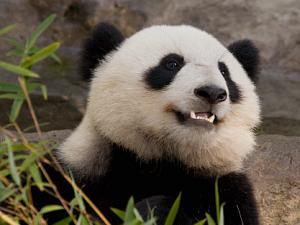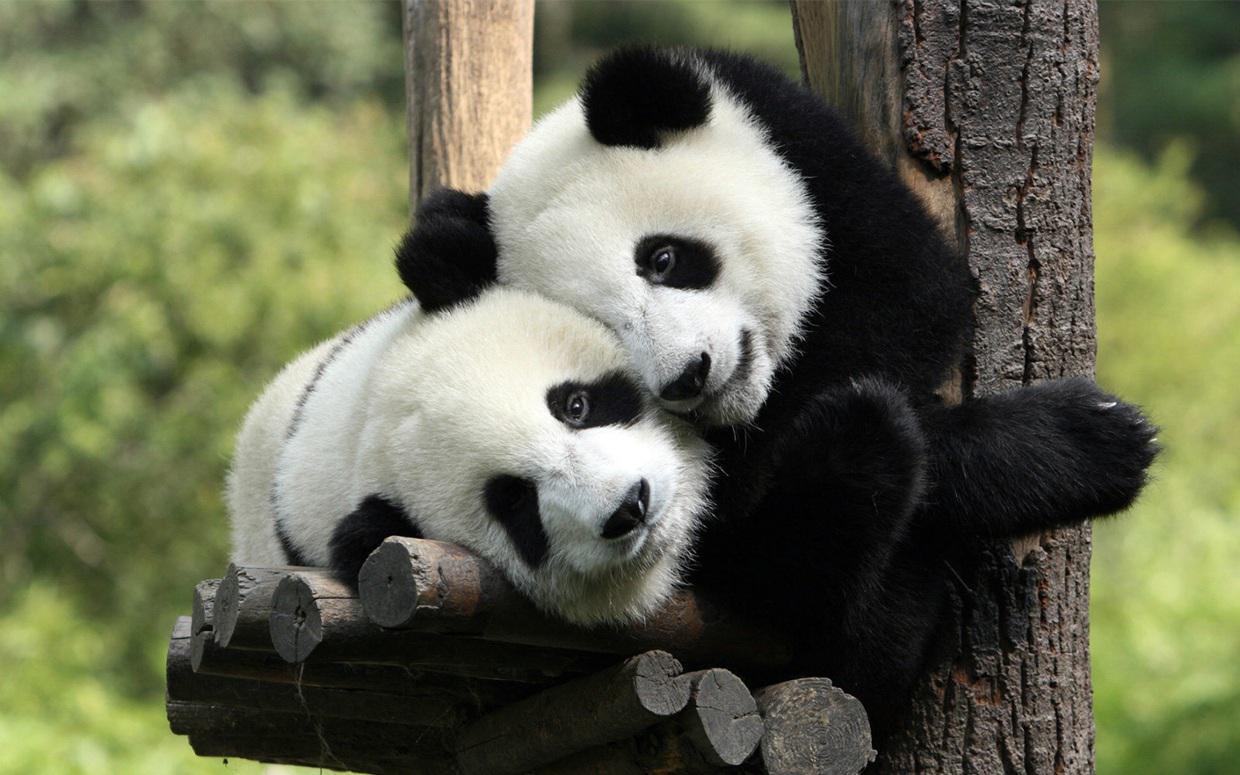The first image is the image on the left, the second image is the image on the right. Examine the images to the left and right. Is the description "An image shows two pandas in close contact." accurate? Answer yes or no. Yes. The first image is the image on the left, the second image is the image on the right. Evaluate the accuracy of this statement regarding the images: "The panda in at least one of the images is holding a bamboo shoot.". Is it true? Answer yes or no. No. 